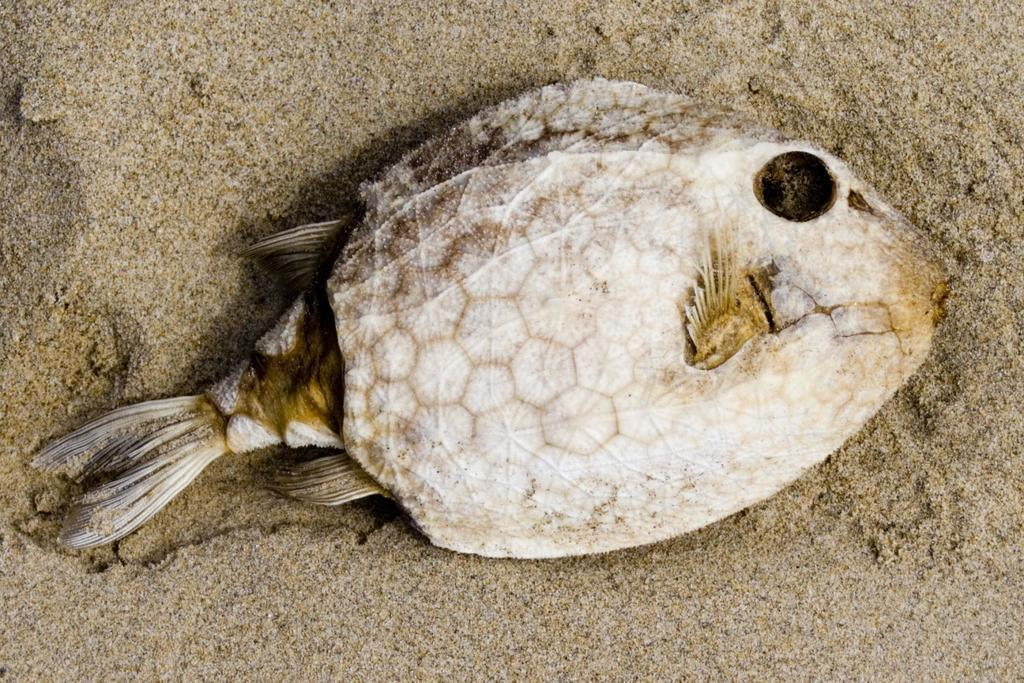What type of animal is in the image? There is a fish in the image. Where is the fish located? The fish is on the sand. What is the condition of the fish? The fish appears to be dead. What type of pie is the fish holding in the image? There is no pie present in the image, and the fish is not holding anything. 